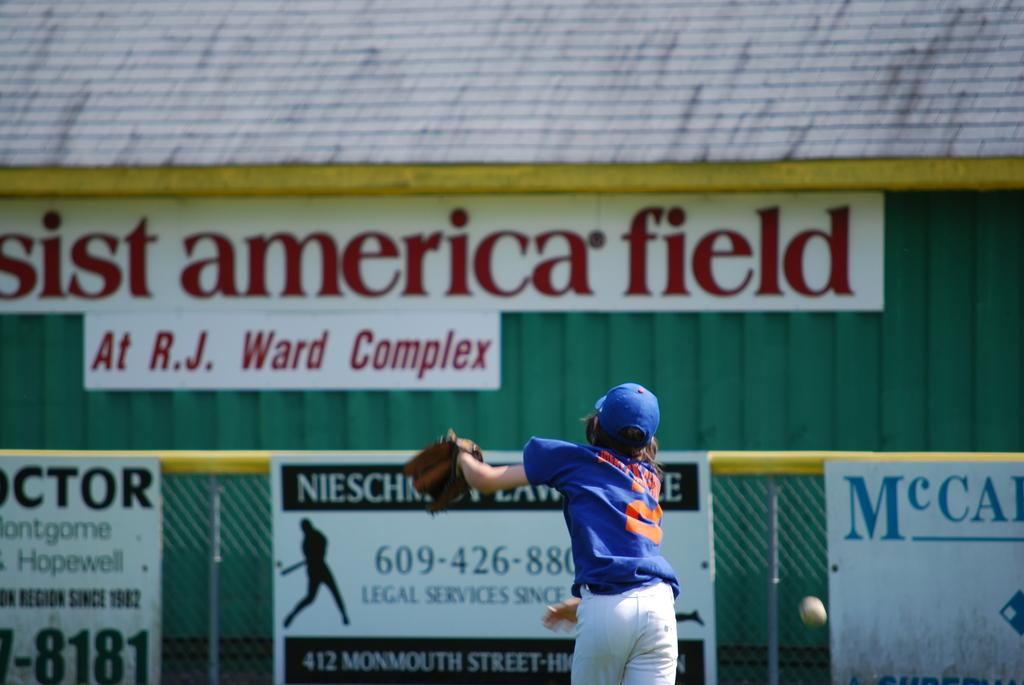<image>
Render a clear and concise summary of the photo. A baseball player in front of a sign that says America Field. 